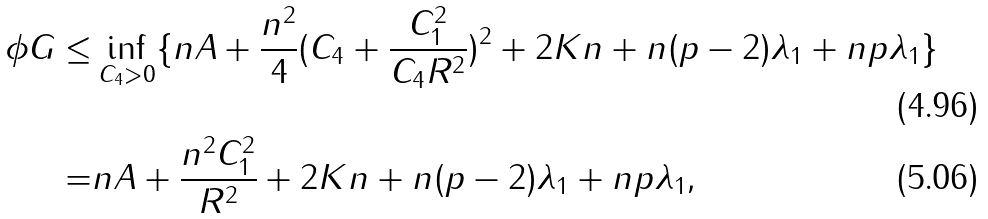<formula> <loc_0><loc_0><loc_500><loc_500>\phi G \leq & \inf _ { C _ { 4 } > 0 } \{ n A + \frac { n ^ { 2 } } { 4 } ( C _ { 4 } + \frac { C _ { 1 } ^ { 2 } } { C _ { 4 } R ^ { 2 } } ) ^ { 2 } + 2 K n + n ( p - 2 ) \lambda _ { 1 } + n p \lambda _ { 1 } \} \\ = & n A + \frac { n ^ { 2 } C _ { 1 } ^ { 2 } } { R ^ { 2 } } + 2 K n + n ( p - 2 ) \lambda _ { 1 } + n p \lambda _ { 1 } ,</formula> 